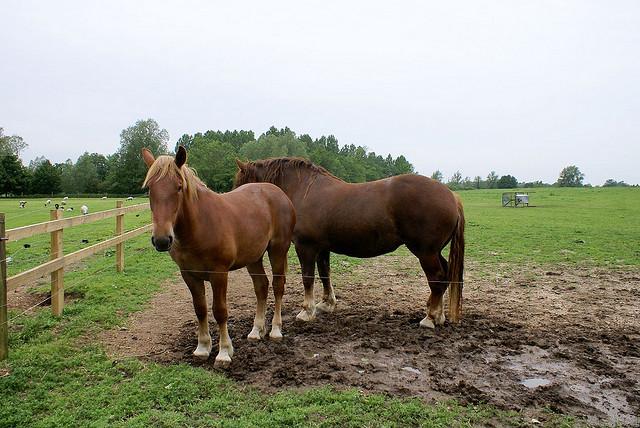What number of grass blades are in the field?
Give a very brief answer. Many. What type of animal is pictured?
Give a very brief answer. Horse. How many horses in the fence?
Give a very brief answer. 2. Is there a house?
Short answer required. No. Are these horses in a show?
Be succinct. No. Are the horses wearing socks?
Short answer required. No. What is the name of these animal?
Short answer required. Horse. How many animals?
Give a very brief answer. 2. Is there any sheep on the other side of the fence?
Give a very brief answer. Yes. Are the horses fond of each other?
Write a very short answer. Yes. What sound do these animals make?
Be succinct. Neigh. Do these horses have plenty of room to roam?
Be succinct. Yes. Is there a vehicle by either house?
Give a very brief answer. No. Is the horse cold?
Short answer required. No. Are the horses racing?
Quick response, please. No. What kind of animals are these?
Answer briefly. Horses. 